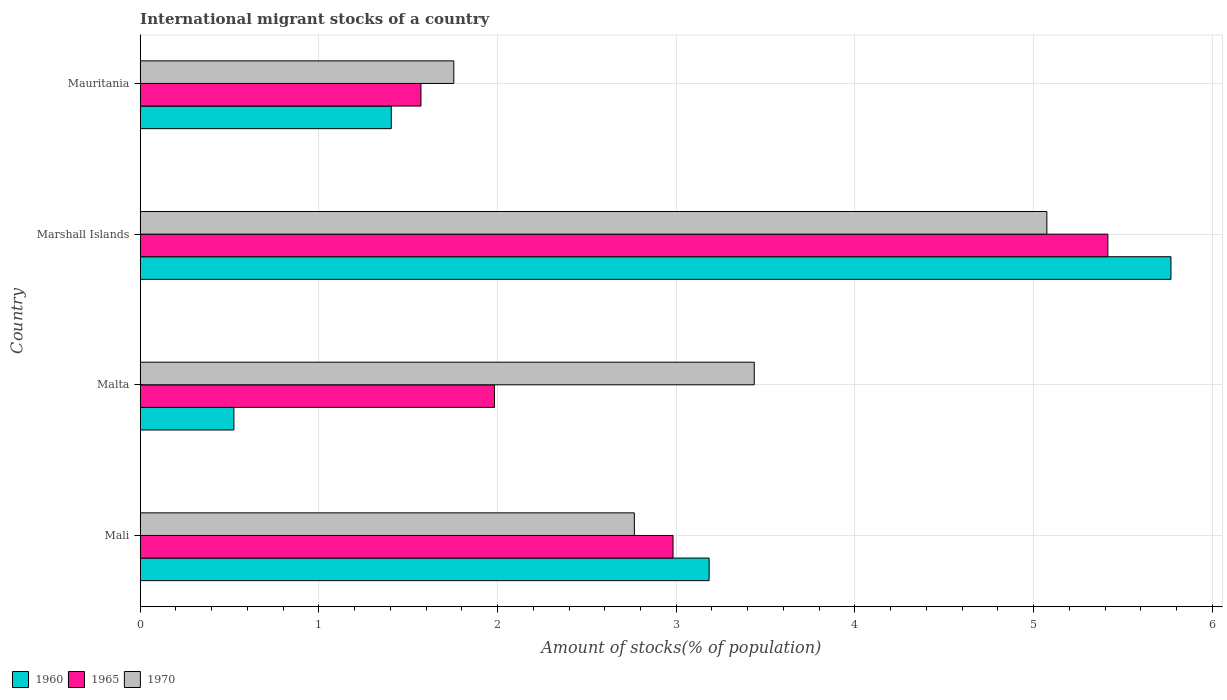How many different coloured bars are there?
Keep it short and to the point. 3. How many groups of bars are there?
Your answer should be compact. 4. Are the number of bars on each tick of the Y-axis equal?
Your response must be concise. Yes. What is the label of the 4th group of bars from the top?
Your answer should be compact. Mali. In how many cases, is the number of bars for a given country not equal to the number of legend labels?
Offer a terse response. 0. What is the amount of stocks in in 1965 in Malta?
Your answer should be compact. 1.98. Across all countries, what is the maximum amount of stocks in in 1970?
Offer a very short reply. 5.07. Across all countries, what is the minimum amount of stocks in in 1970?
Your answer should be compact. 1.75. In which country was the amount of stocks in in 1970 maximum?
Provide a succinct answer. Marshall Islands. In which country was the amount of stocks in in 1965 minimum?
Provide a succinct answer. Mauritania. What is the total amount of stocks in in 1965 in the graph?
Your answer should be very brief. 11.95. What is the difference between the amount of stocks in in 1960 in Mali and that in Mauritania?
Ensure brevity in your answer.  1.78. What is the difference between the amount of stocks in in 1970 in Marshall Islands and the amount of stocks in in 1960 in Mali?
Make the answer very short. 1.89. What is the average amount of stocks in in 1960 per country?
Provide a succinct answer. 2.72. What is the difference between the amount of stocks in in 1960 and amount of stocks in in 1970 in Mali?
Make the answer very short. 0.42. What is the ratio of the amount of stocks in in 1960 in Malta to that in Marshall Islands?
Ensure brevity in your answer.  0.09. Is the difference between the amount of stocks in in 1960 in Mali and Mauritania greater than the difference between the amount of stocks in in 1970 in Mali and Mauritania?
Keep it short and to the point. Yes. What is the difference between the highest and the second highest amount of stocks in in 1965?
Offer a very short reply. 2.43. What is the difference between the highest and the lowest amount of stocks in in 1965?
Your answer should be compact. 3.84. In how many countries, is the amount of stocks in in 1965 greater than the average amount of stocks in in 1965 taken over all countries?
Make the answer very short. 1. Is the sum of the amount of stocks in in 1970 in Mali and Mauritania greater than the maximum amount of stocks in in 1965 across all countries?
Your answer should be very brief. No. What does the 2nd bar from the top in Malta represents?
Your answer should be compact. 1965. How many bars are there?
Your answer should be compact. 12. What is the difference between two consecutive major ticks on the X-axis?
Ensure brevity in your answer.  1. Does the graph contain grids?
Offer a very short reply. Yes. Where does the legend appear in the graph?
Give a very brief answer. Bottom left. What is the title of the graph?
Your answer should be very brief. International migrant stocks of a country. What is the label or title of the X-axis?
Provide a succinct answer. Amount of stocks(% of population). What is the Amount of stocks(% of population) in 1960 in Mali?
Provide a succinct answer. 3.18. What is the Amount of stocks(% of population) in 1965 in Mali?
Ensure brevity in your answer.  2.98. What is the Amount of stocks(% of population) of 1970 in Mali?
Your answer should be very brief. 2.77. What is the Amount of stocks(% of population) in 1960 in Malta?
Ensure brevity in your answer.  0.52. What is the Amount of stocks(% of population) of 1965 in Malta?
Make the answer very short. 1.98. What is the Amount of stocks(% of population) in 1970 in Malta?
Your response must be concise. 3.44. What is the Amount of stocks(% of population) in 1960 in Marshall Islands?
Provide a succinct answer. 5.77. What is the Amount of stocks(% of population) in 1965 in Marshall Islands?
Keep it short and to the point. 5.42. What is the Amount of stocks(% of population) in 1970 in Marshall Islands?
Your answer should be compact. 5.07. What is the Amount of stocks(% of population) of 1960 in Mauritania?
Make the answer very short. 1.41. What is the Amount of stocks(% of population) in 1965 in Mauritania?
Offer a very short reply. 1.57. What is the Amount of stocks(% of population) in 1970 in Mauritania?
Provide a short and direct response. 1.75. Across all countries, what is the maximum Amount of stocks(% of population) of 1960?
Provide a short and direct response. 5.77. Across all countries, what is the maximum Amount of stocks(% of population) in 1965?
Provide a succinct answer. 5.42. Across all countries, what is the maximum Amount of stocks(% of population) of 1970?
Make the answer very short. 5.07. Across all countries, what is the minimum Amount of stocks(% of population) in 1960?
Give a very brief answer. 0.52. Across all countries, what is the minimum Amount of stocks(% of population) of 1965?
Your answer should be very brief. 1.57. Across all countries, what is the minimum Amount of stocks(% of population) in 1970?
Offer a very short reply. 1.75. What is the total Amount of stocks(% of population) of 1960 in the graph?
Provide a succinct answer. 10.88. What is the total Amount of stocks(% of population) of 1965 in the graph?
Provide a short and direct response. 11.95. What is the total Amount of stocks(% of population) in 1970 in the graph?
Ensure brevity in your answer.  13.03. What is the difference between the Amount of stocks(% of population) of 1960 in Mali and that in Malta?
Offer a very short reply. 2.66. What is the difference between the Amount of stocks(% of population) in 1965 in Mali and that in Malta?
Your response must be concise. 1. What is the difference between the Amount of stocks(% of population) in 1970 in Mali and that in Malta?
Keep it short and to the point. -0.67. What is the difference between the Amount of stocks(% of population) in 1960 in Mali and that in Marshall Islands?
Offer a very short reply. -2.58. What is the difference between the Amount of stocks(% of population) of 1965 in Mali and that in Marshall Islands?
Keep it short and to the point. -2.43. What is the difference between the Amount of stocks(% of population) of 1970 in Mali and that in Marshall Islands?
Make the answer very short. -2.31. What is the difference between the Amount of stocks(% of population) of 1960 in Mali and that in Mauritania?
Provide a short and direct response. 1.78. What is the difference between the Amount of stocks(% of population) of 1965 in Mali and that in Mauritania?
Make the answer very short. 1.41. What is the difference between the Amount of stocks(% of population) of 1970 in Mali and that in Mauritania?
Provide a succinct answer. 1.01. What is the difference between the Amount of stocks(% of population) of 1960 in Malta and that in Marshall Islands?
Offer a very short reply. -5.24. What is the difference between the Amount of stocks(% of population) in 1965 in Malta and that in Marshall Islands?
Your response must be concise. -3.43. What is the difference between the Amount of stocks(% of population) of 1970 in Malta and that in Marshall Islands?
Offer a very short reply. -1.64. What is the difference between the Amount of stocks(% of population) in 1960 in Malta and that in Mauritania?
Make the answer very short. -0.88. What is the difference between the Amount of stocks(% of population) in 1965 in Malta and that in Mauritania?
Make the answer very short. 0.41. What is the difference between the Amount of stocks(% of population) in 1970 in Malta and that in Mauritania?
Provide a short and direct response. 1.68. What is the difference between the Amount of stocks(% of population) of 1960 in Marshall Islands and that in Mauritania?
Your response must be concise. 4.36. What is the difference between the Amount of stocks(% of population) in 1965 in Marshall Islands and that in Mauritania?
Give a very brief answer. 3.84. What is the difference between the Amount of stocks(% of population) in 1970 in Marshall Islands and that in Mauritania?
Provide a short and direct response. 3.32. What is the difference between the Amount of stocks(% of population) of 1960 in Mali and the Amount of stocks(% of population) of 1965 in Malta?
Give a very brief answer. 1.2. What is the difference between the Amount of stocks(% of population) of 1960 in Mali and the Amount of stocks(% of population) of 1970 in Malta?
Ensure brevity in your answer.  -0.25. What is the difference between the Amount of stocks(% of population) in 1965 in Mali and the Amount of stocks(% of population) in 1970 in Malta?
Your response must be concise. -0.45. What is the difference between the Amount of stocks(% of population) of 1960 in Mali and the Amount of stocks(% of population) of 1965 in Marshall Islands?
Your answer should be very brief. -2.23. What is the difference between the Amount of stocks(% of population) in 1960 in Mali and the Amount of stocks(% of population) in 1970 in Marshall Islands?
Your answer should be compact. -1.89. What is the difference between the Amount of stocks(% of population) in 1965 in Mali and the Amount of stocks(% of population) in 1970 in Marshall Islands?
Provide a succinct answer. -2.09. What is the difference between the Amount of stocks(% of population) in 1960 in Mali and the Amount of stocks(% of population) in 1965 in Mauritania?
Give a very brief answer. 1.61. What is the difference between the Amount of stocks(% of population) of 1960 in Mali and the Amount of stocks(% of population) of 1970 in Mauritania?
Offer a very short reply. 1.43. What is the difference between the Amount of stocks(% of population) of 1965 in Mali and the Amount of stocks(% of population) of 1970 in Mauritania?
Your answer should be very brief. 1.23. What is the difference between the Amount of stocks(% of population) in 1960 in Malta and the Amount of stocks(% of population) in 1965 in Marshall Islands?
Provide a short and direct response. -4.89. What is the difference between the Amount of stocks(% of population) of 1960 in Malta and the Amount of stocks(% of population) of 1970 in Marshall Islands?
Offer a terse response. -4.55. What is the difference between the Amount of stocks(% of population) in 1965 in Malta and the Amount of stocks(% of population) in 1970 in Marshall Islands?
Make the answer very short. -3.09. What is the difference between the Amount of stocks(% of population) of 1960 in Malta and the Amount of stocks(% of population) of 1965 in Mauritania?
Offer a very short reply. -1.05. What is the difference between the Amount of stocks(% of population) of 1960 in Malta and the Amount of stocks(% of population) of 1970 in Mauritania?
Provide a short and direct response. -1.23. What is the difference between the Amount of stocks(% of population) of 1965 in Malta and the Amount of stocks(% of population) of 1970 in Mauritania?
Offer a terse response. 0.23. What is the difference between the Amount of stocks(% of population) of 1960 in Marshall Islands and the Amount of stocks(% of population) of 1965 in Mauritania?
Keep it short and to the point. 4.2. What is the difference between the Amount of stocks(% of population) in 1960 in Marshall Islands and the Amount of stocks(% of population) in 1970 in Mauritania?
Your answer should be very brief. 4.01. What is the difference between the Amount of stocks(% of population) in 1965 in Marshall Islands and the Amount of stocks(% of population) in 1970 in Mauritania?
Provide a succinct answer. 3.66. What is the average Amount of stocks(% of population) in 1960 per country?
Offer a very short reply. 2.72. What is the average Amount of stocks(% of population) in 1965 per country?
Make the answer very short. 2.99. What is the average Amount of stocks(% of population) in 1970 per country?
Your response must be concise. 3.26. What is the difference between the Amount of stocks(% of population) of 1960 and Amount of stocks(% of population) of 1965 in Mali?
Provide a short and direct response. 0.2. What is the difference between the Amount of stocks(% of population) of 1960 and Amount of stocks(% of population) of 1970 in Mali?
Your answer should be compact. 0.42. What is the difference between the Amount of stocks(% of population) in 1965 and Amount of stocks(% of population) in 1970 in Mali?
Provide a short and direct response. 0.22. What is the difference between the Amount of stocks(% of population) in 1960 and Amount of stocks(% of population) in 1965 in Malta?
Make the answer very short. -1.46. What is the difference between the Amount of stocks(% of population) in 1960 and Amount of stocks(% of population) in 1970 in Malta?
Make the answer very short. -2.91. What is the difference between the Amount of stocks(% of population) of 1965 and Amount of stocks(% of population) of 1970 in Malta?
Your response must be concise. -1.45. What is the difference between the Amount of stocks(% of population) in 1960 and Amount of stocks(% of population) in 1965 in Marshall Islands?
Provide a short and direct response. 0.35. What is the difference between the Amount of stocks(% of population) of 1960 and Amount of stocks(% of population) of 1970 in Marshall Islands?
Your answer should be compact. 0.69. What is the difference between the Amount of stocks(% of population) in 1965 and Amount of stocks(% of population) in 1970 in Marshall Islands?
Offer a very short reply. 0.34. What is the difference between the Amount of stocks(% of population) of 1960 and Amount of stocks(% of population) of 1965 in Mauritania?
Provide a short and direct response. -0.17. What is the difference between the Amount of stocks(% of population) in 1960 and Amount of stocks(% of population) in 1970 in Mauritania?
Your answer should be very brief. -0.35. What is the difference between the Amount of stocks(% of population) of 1965 and Amount of stocks(% of population) of 1970 in Mauritania?
Your answer should be very brief. -0.18. What is the ratio of the Amount of stocks(% of population) of 1960 in Mali to that in Malta?
Offer a terse response. 6.07. What is the ratio of the Amount of stocks(% of population) in 1965 in Mali to that in Malta?
Make the answer very short. 1.5. What is the ratio of the Amount of stocks(% of population) of 1970 in Mali to that in Malta?
Your response must be concise. 0.8. What is the ratio of the Amount of stocks(% of population) in 1960 in Mali to that in Marshall Islands?
Your answer should be very brief. 0.55. What is the ratio of the Amount of stocks(% of population) of 1965 in Mali to that in Marshall Islands?
Keep it short and to the point. 0.55. What is the ratio of the Amount of stocks(% of population) of 1970 in Mali to that in Marshall Islands?
Your answer should be very brief. 0.55. What is the ratio of the Amount of stocks(% of population) in 1960 in Mali to that in Mauritania?
Ensure brevity in your answer.  2.27. What is the ratio of the Amount of stocks(% of population) in 1965 in Mali to that in Mauritania?
Make the answer very short. 1.9. What is the ratio of the Amount of stocks(% of population) of 1970 in Mali to that in Mauritania?
Your response must be concise. 1.58. What is the ratio of the Amount of stocks(% of population) in 1960 in Malta to that in Marshall Islands?
Offer a very short reply. 0.09. What is the ratio of the Amount of stocks(% of population) in 1965 in Malta to that in Marshall Islands?
Keep it short and to the point. 0.37. What is the ratio of the Amount of stocks(% of population) of 1970 in Malta to that in Marshall Islands?
Your answer should be compact. 0.68. What is the ratio of the Amount of stocks(% of population) in 1960 in Malta to that in Mauritania?
Provide a short and direct response. 0.37. What is the ratio of the Amount of stocks(% of population) in 1965 in Malta to that in Mauritania?
Your response must be concise. 1.26. What is the ratio of the Amount of stocks(% of population) of 1970 in Malta to that in Mauritania?
Ensure brevity in your answer.  1.96. What is the ratio of the Amount of stocks(% of population) in 1960 in Marshall Islands to that in Mauritania?
Ensure brevity in your answer.  4.11. What is the ratio of the Amount of stocks(% of population) of 1965 in Marshall Islands to that in Mauritania?
Your answer should be compact. 3.45. What is the ratio of the Amount of stocks(% of population) in 1970 in Marshall Islands to that in Mauritania?
Your answer should be very brief. 2.89. What is the difference between the highest and the second highest Amount of stocks(% of population) of 1960?
Ensure brevity in your answer.  2.58. What is the difference between the highest and the second highest Amount of stocks(% of population) of 1965?
Make the answer very short. 2.43. What is the difference between the highest and the second highest Amount of stocks(% of population) in 1970?
Offer a terse response. 1.64. What is the difference between the highest and the lowest Amount of stocks(% of population) of 1960?
Provide a succinct answer. 5.24. What is the difference between the highest and the lowest Amount of stocks(% of population) in 1965?
Offer a terse response. 3.84. What is the difference between the highest and the lowest Amount of stocks(% of population) in 1970?
Keep it short and to the point. 3.32. 